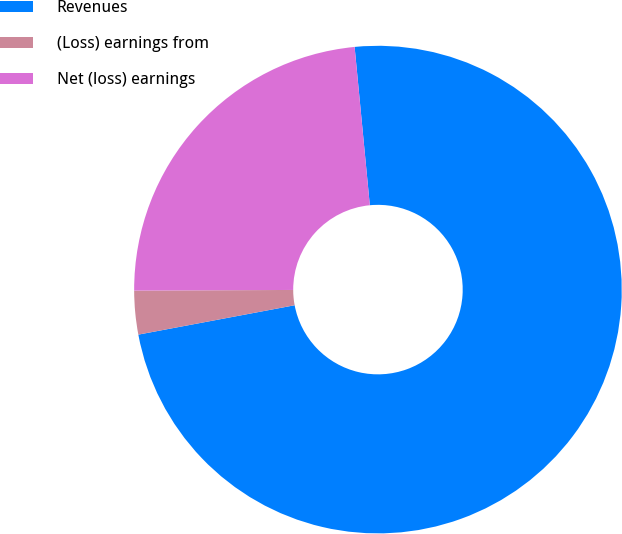<chart> <loc_0><loc_0><loc_500><loc_500><pie_chart><fcel>Revenues<fcel>(Loss) earnings from<fcel>Net (loss) earnings<nl><fcel>73.57%<fcel>2.89%<fcel>23.54%<nl></chart> 